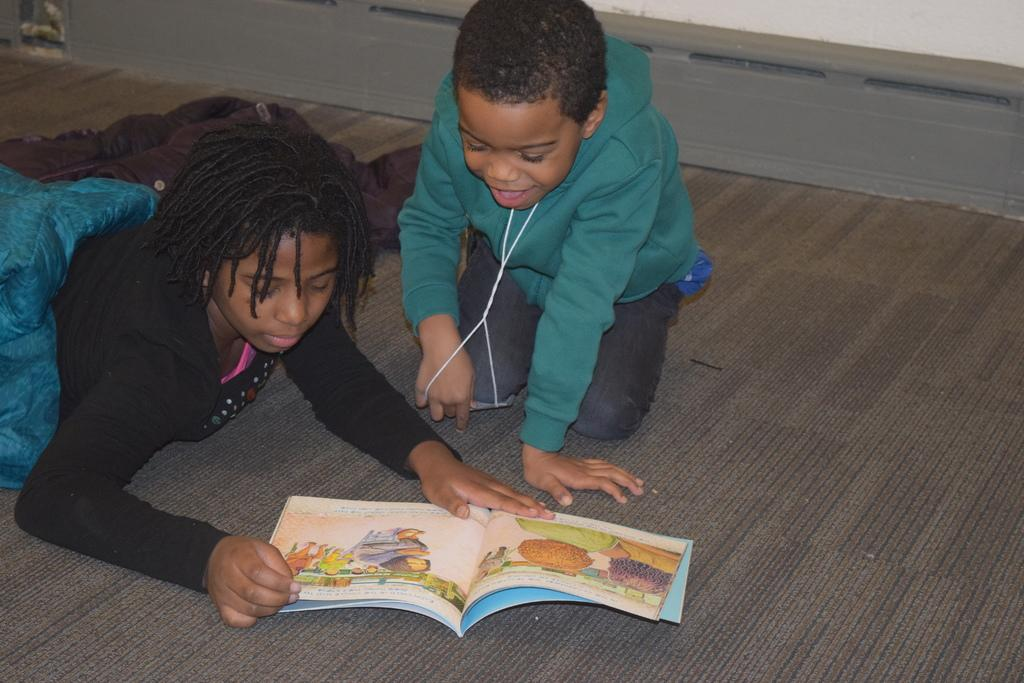How many people are in the image? There are two people in the image. Where are the two people located? The two people are on the floor. What are the two people doing in the image? The two people are reading a book. What type of lamp is being used by the people in the image? There is no lamp present in the image; the two people are reading a book on the floor. 